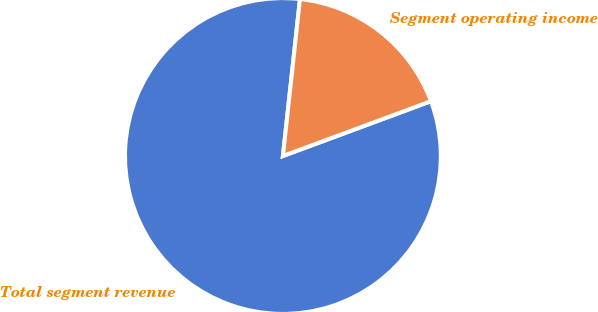<chart> <loc_0><loc_0><loc_500><loc_500><pie_chart><fcel>Total segment revenue<fcel>Segment operating income<nl><fcel>82.37%<fcel>17.63%<nl></chart> 